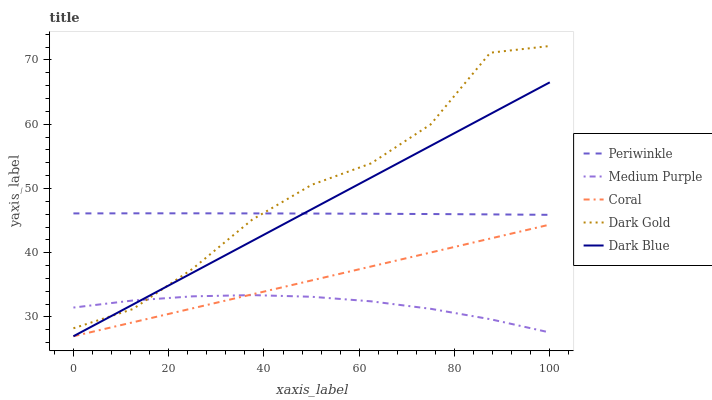Does Medium Purple have the minimum area under the curve?
Answer yes or no. Yes. Does Dark Gold have the maximum area under the curve?
Answer yes or no. Yes. Does Dark Blue have the minimum area under the curve?
Answer yes or no. No. Does Dark Blue have the maximum area under the curve?
Answer yes or no. No. Is Dark Blue the smoothest?
Answer yes or no. Yes. Is Dark Gold the roughest?
Answer yes or no. Yes. Is Coral the smoothest?
Answer yes or no. No. Is Coral the roughest?
Answer yes or no. No. Does Dark Blue have the lowest value?
Answer yes or no. Yes. Does Periwinkle have the lowest value?
Answer yes or no. No. Does Dark Gold have the highest value?
Answer yes or no. Yes. Does Dark Blue have the highest value?
Answer yes or no. No. Is Coral less than Dark Gold?
Answer yes or no. Yes. Is Periwinkle greater than Medium Purple?
Answer yes or no. Yes. Does Periwinkle intersect Dark Gold?
Answer yes or no. Yes. Is Periwinkle less than Dark Gold?
Answer yes or no. No. Is Periwinkle greater than Dark Gold?
Answer yes or no. No. Does Coral intersect Dark Gold?
Answer yes or no. No. 